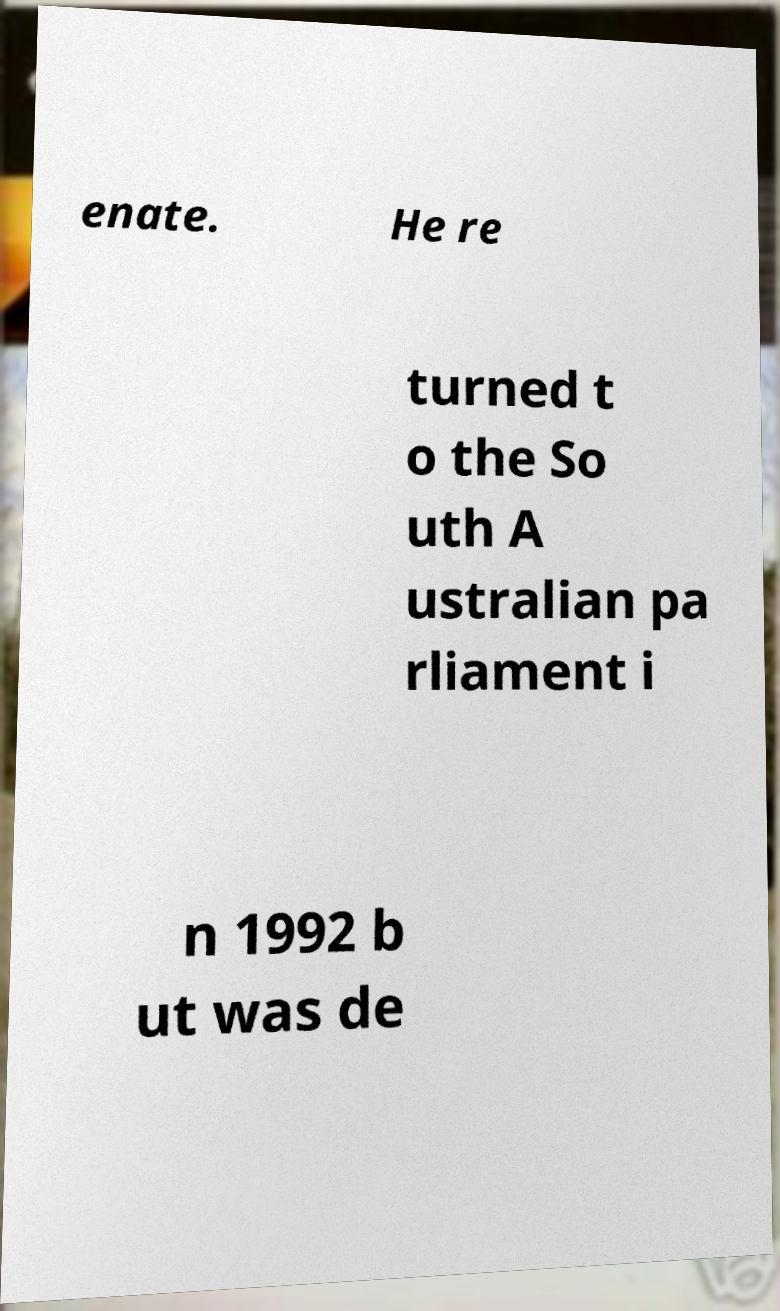Please identify and transcribe the text found in this image. enate. He re turned t o the So uth A ustralian pa rliament i n 1992 b ut was de 